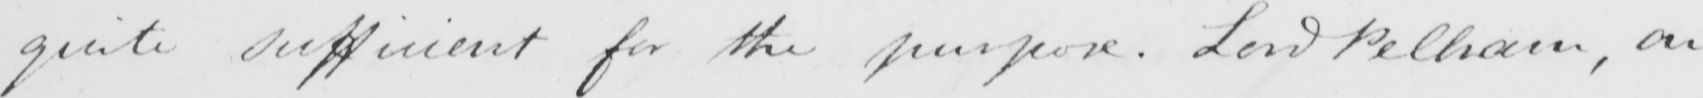Transcribe the text shown in this historical manuscript line. quite sufficient for the purpose . Lord Pelham , on 